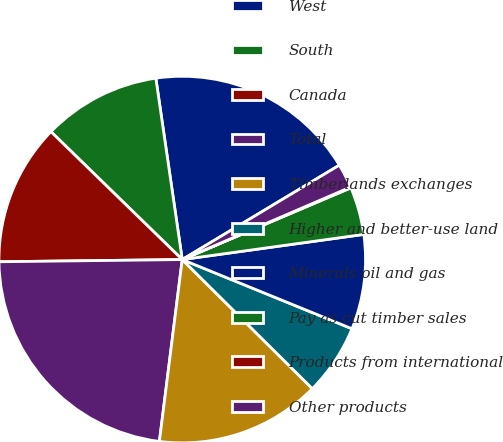Convert chart. <chart><loc_0><loc_0><loc_500><loc_500><pie_chart><fcel>West<fcel>South<fcel>Canada<fcel>Total<fcel>Timberlands exchanges<fcel>Higher and better-use land<fcel>Minerals oil and gas<fcel>Pay as cut timber sales<fcel>Products from international<fcel>Other products<nl><fcel>18.69%<fcel>10.41%<fcel>12.48%<fcel>22.82%<fcel>14.55%<fcel>6.28%<fcel>8.35%<fcel>4.21%<fcel>0.07%<fcel>2.14%<nl></chart> 